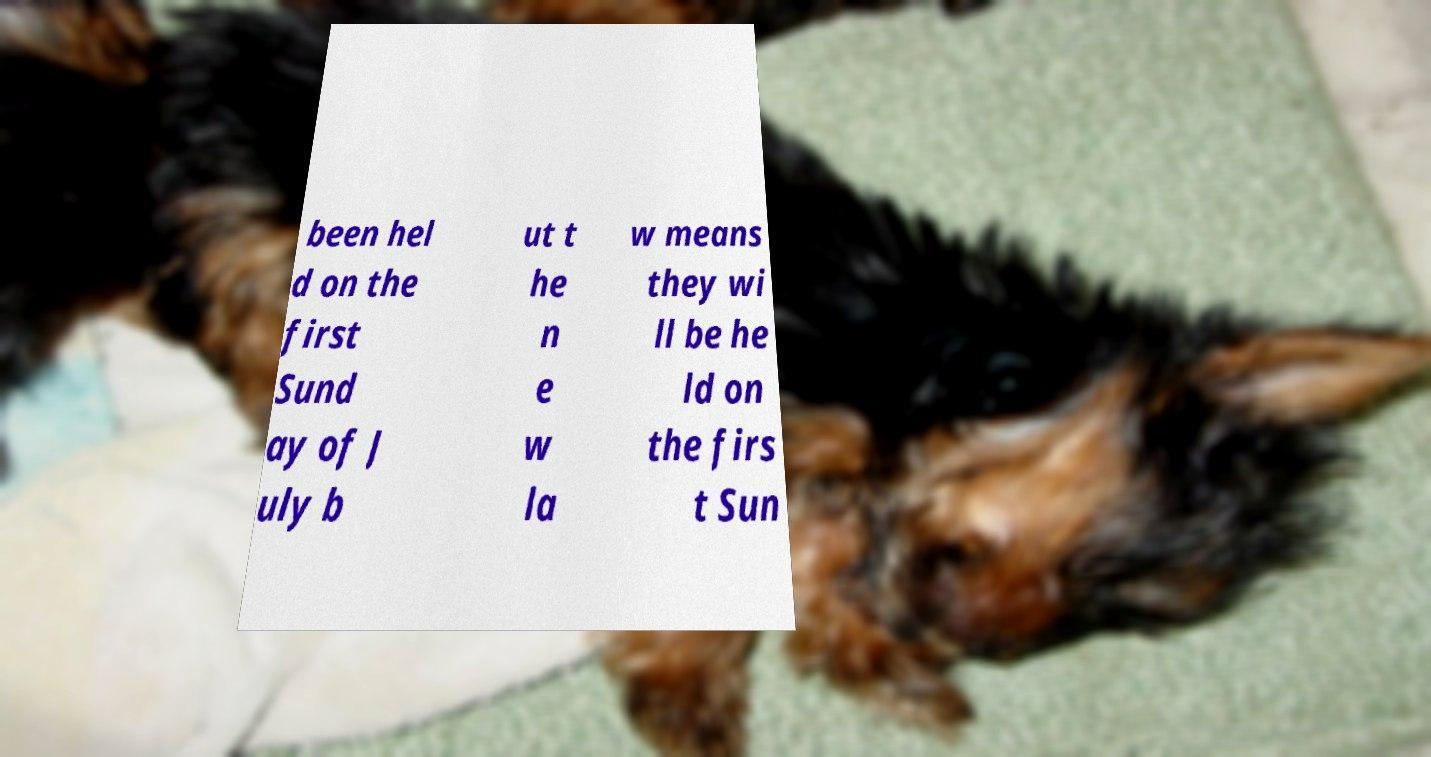Please read and relay the text visible in this image. What does it say? been hel d on the first Sund ay of J uly b ut t he n e w la w means they wi ll be he ld on the firs t Sun 